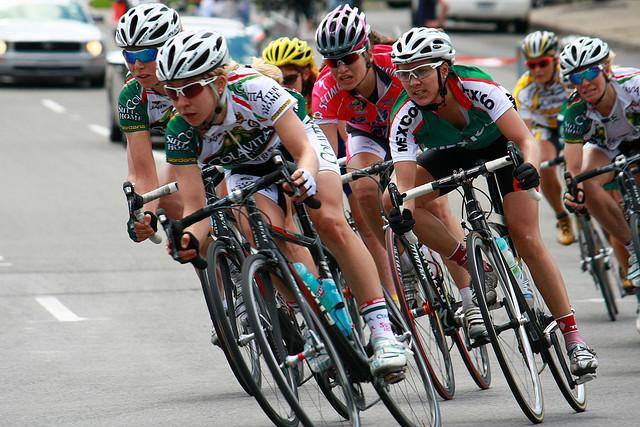What are the women participating in?

Choices:
A) exercise class
B) work group
C) group meeting
D) race race 